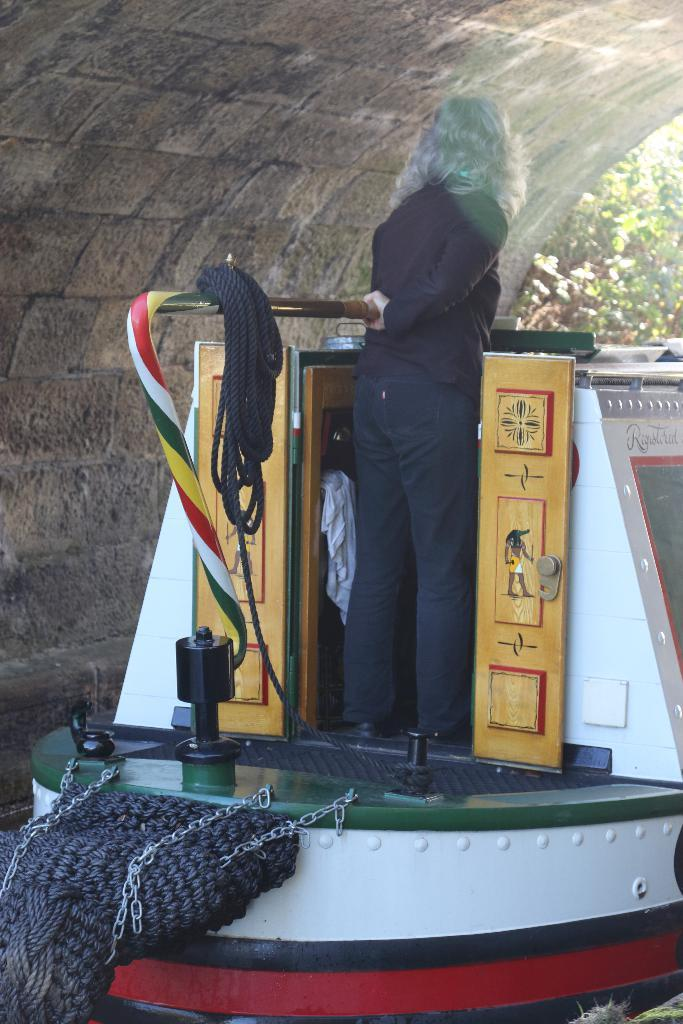What is the lady doing in the image? The lady is standing on a boat in the image. What can be seen in the background of the image? There is a wall and trees visible in the background of the image. How many horses are present in the image? There are no horses present in the image. What are the girls doing in the image? There are no girls present in the image. 